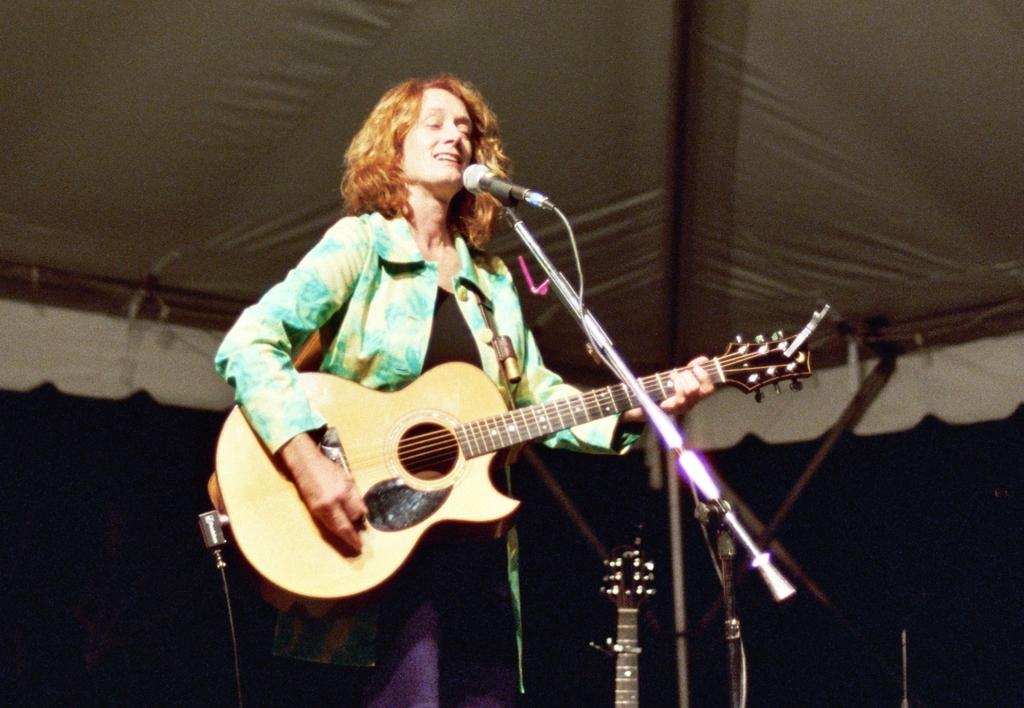Who is the main subject in the image? There is a woman in the image. Where is the woman positioned in the image? The woman is standing in the middle of the image. What is the woman doing in the image? The woman is playing a guitar and singing on a microphone. What can be seen at the top of the image? There is a tent at the top of the image. What type of square is the woman's daughter playing with in the image? There is no mention of a square or the woman's daughter in the image. 